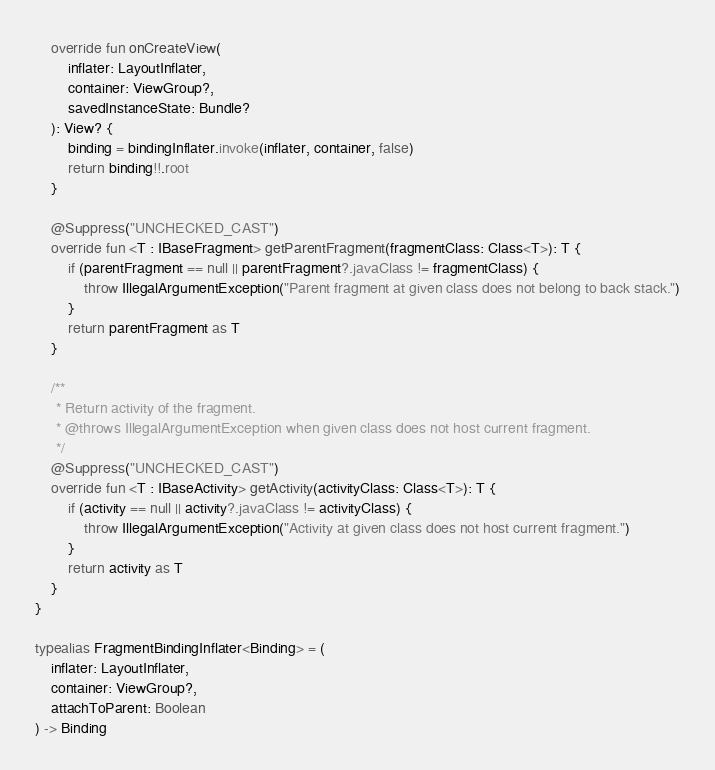Convert code to text. <code><loc_0><loc_0><loc_500><loc_500><_Kotlin_>
    override fun onCreateView(
        inflater: LayoutInflater,
        container: ViewGroup?,
        savedInstanceState: Bundle?
    ): View? {
        binding = bindingInflater.invoke(inflater, container, false)
        return binding!!.root
    }

    @Suppress("UNCHECKED_CAST")
    override fun <T : IBaseFragment> getParentFragment(fragmentClass: Class<T>): T {
        if (parentFragment == null || parentFragment?.javaClass != fragmentClass) {
            throw IllegalArgumentException("Parent fragment at given class does not belong to back stack.")
        }
        return parentFragment as T
    }

    /**
     * Return activity of the fragment.
     * @throws IllegalArgumentException when given class does not host current fragment.
     */
    @Suppress("UNCHECKED_CAST")
    override fun <T : IBaseActivity> getActivity(activityClass: Class<T>): T {
        if (activity == null || activity?.javaClass != activityClass) {
            throw IllegalArgumentException("Activity at given class does not host current fragment.")
        }
        return activity as T
    }
}

typealias FragmentBindingInflater<Binding> = (
    inflater: LayoutInflater,
    container: ViewGroup?,
    attachToParent: Boolean
) -> Binding</code> 